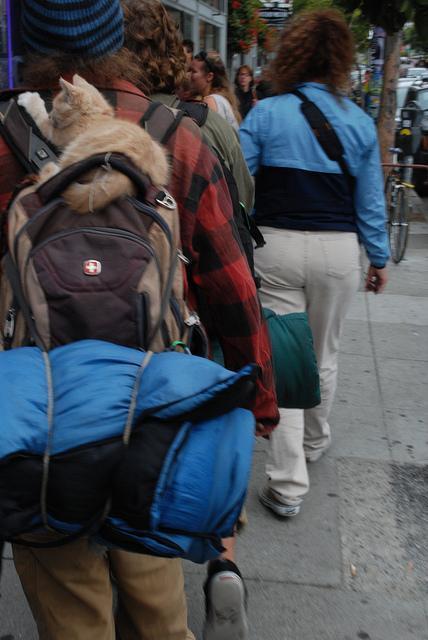How many people are in the picture?
Give a very brief answer. 3. 